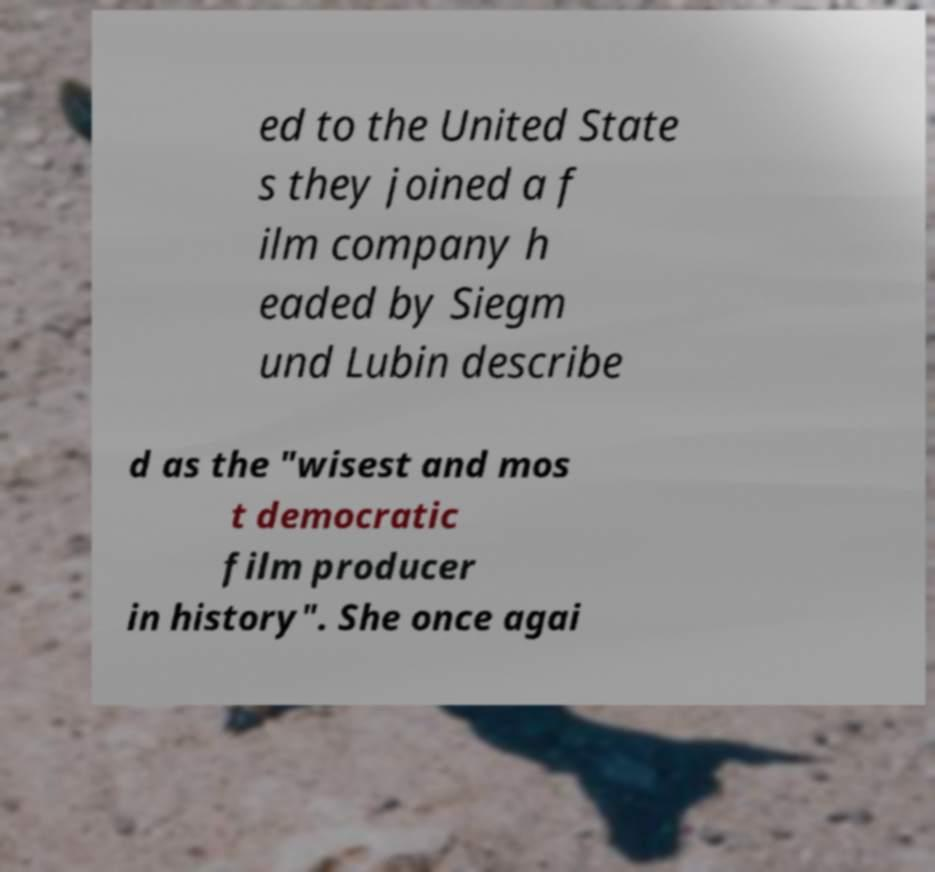Can you accurately transcribe the text from the provided image for me? ed to the United State s they joined a f ilm company h eaded by Siegm und Lubin describe d as the "wisest and mos t democratic film producer in history". She once agai 